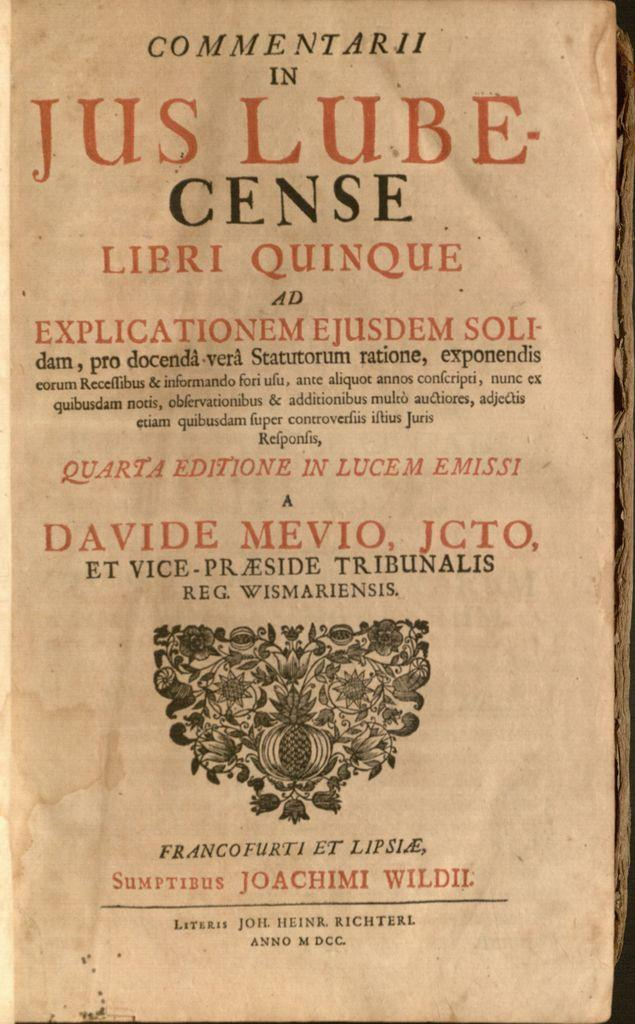<image>
Describe the image concisely. A book is open to the title page which says Commentarii in Jus Lube-Cense. 